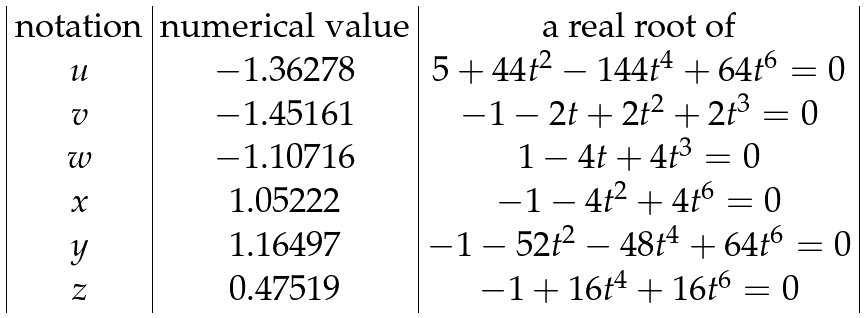<formula> <loc_0><loc_0><loc_500><loc_500>\begin{array} { | c | c | c | } \text {notation} & \text {numerical value} & \text {a real root of} \\ u & - 1 . 3 6 2 7 8 & 5 + 4 4 t ^ { 2 } - 1 4 4 t ^ { 4 } + 6 4 t ^ { 6 } = 0 \\ v & - 1 . 4 5 1 6 1 & - 1 - 2 t + 2 t ^ { 2 } + 2 t ^ { 3 } = 0 \\ w & - 1 . 1 0 7 1 6 & 1 - 4 t + 4 t ^ { 3 } = 0 \\ x & 1 . 0 5 2 2 2 & - 1 - 4 t ^ { 2 } + 4 t ^ { 6 } = 0 \\ y & 1 . 1 6 4 9 7 & - 1 - 5 2 t ^ { 2 } - 4 8 t ^ { 4 } + 6 4 t ^ { 6 } = 0 \\ z & 0 . 4 7 5 1 9 & - 1 + 1 6 t ^ { 4 } + 1 6 t ^ { 6 } = 0 \\ \end{array}</formula> 